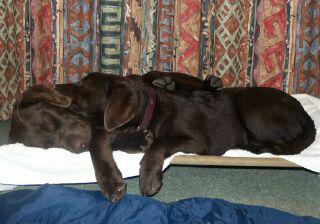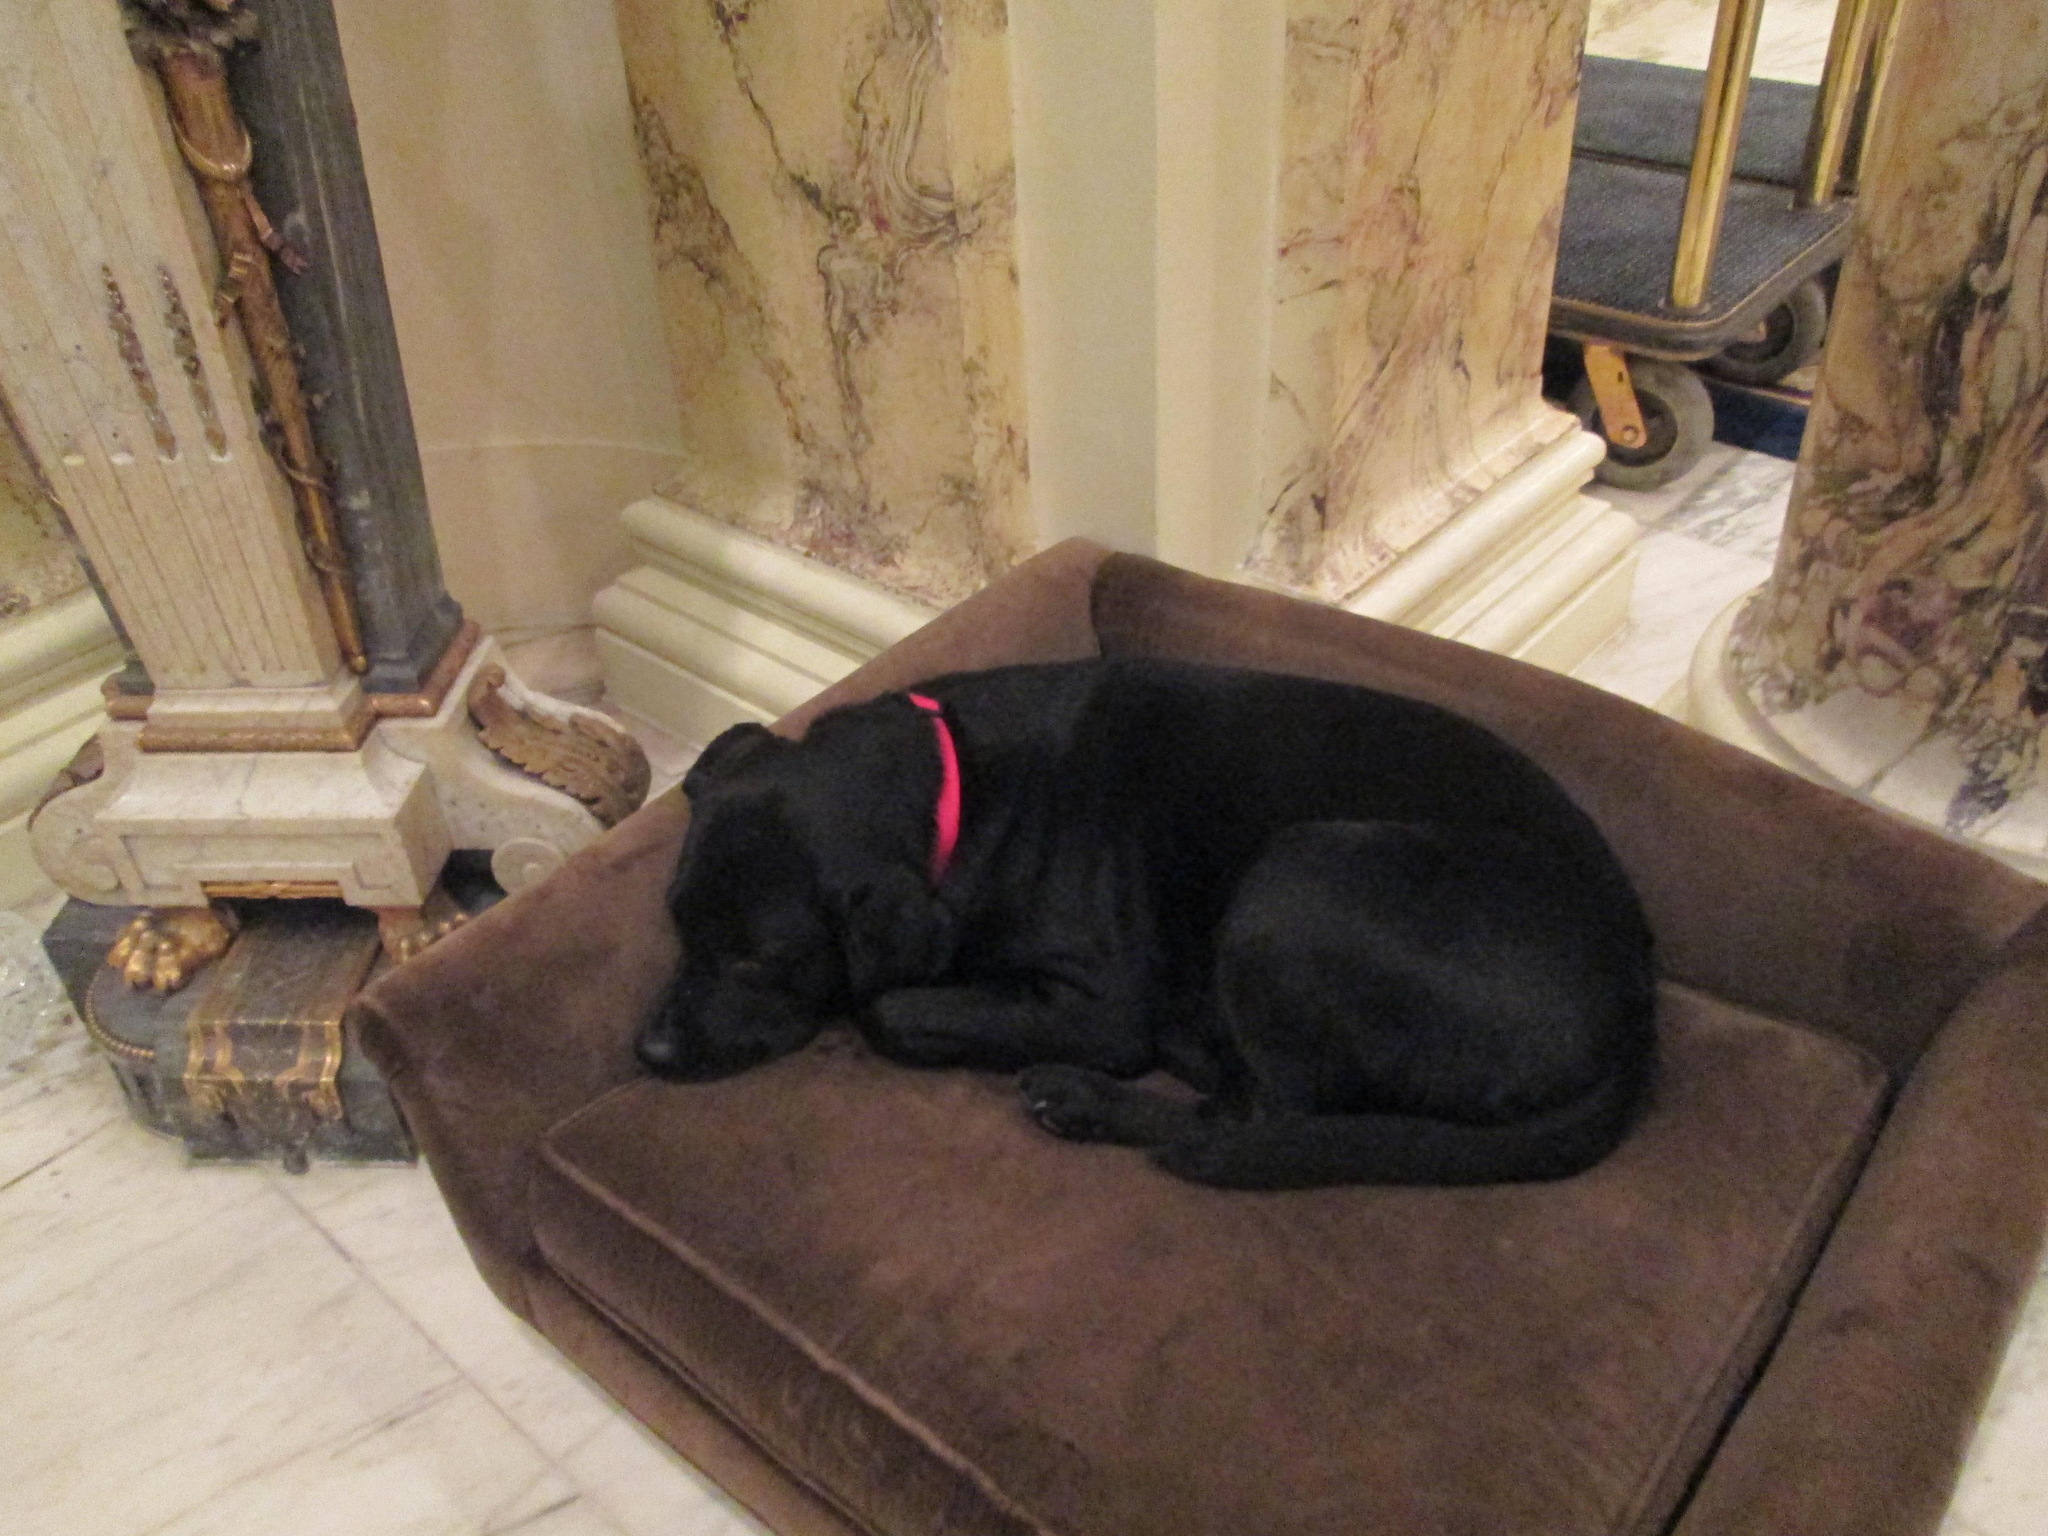The first image is the image on the left, the second image is the image on the right. For the images shown, is this caption "A dog is lying on a couch with its head down." true? Answer yes or no. Yes. The first image is the image on the left, the second image is the image on the right. Given the left and right images, does the statement "An image shows two dogs reclining together on something indoors, with a white fabric under them." hold true? Answer yes or no. Yes. 